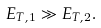Convert formula to latex. <formula><loc_0><loc_0><loc_500><loc_500>E _ { T , 1 } \gg E _ { T , 2 } .</formula> 